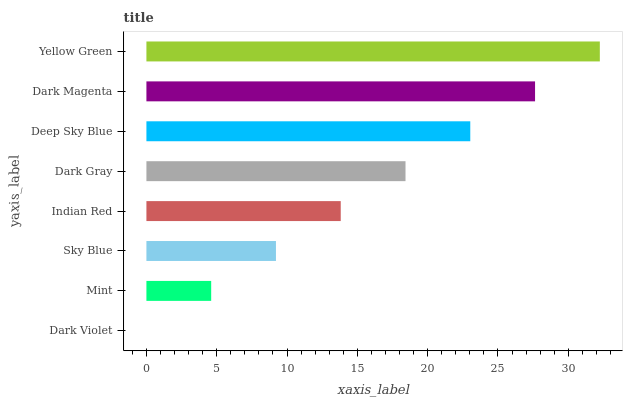Is Dark Violet the minimum?
Answer yes or no. Yes. Is Yellow Green the maximum?
Answer yes or no. Yes. Is Mint the minimum?
Answer yes or no. No. Is Mint the maximum?
Answer yes or no. No. Is Mint greater than Dark Violet?
Answer yes or no. Yes. Is Dark Violet less than Mint?
Answer yes or no. Yes. Is Dark Violet greater than Mint?
Answer yes or no. No. Is Mint less than Dark Violet?
Answer yes or no. No. Is Dark Gray the high median?
Answer yes or no. Yes. Is Indian Red the low median?
Answer yes or no. Yes. Is Dark Magenta the high median?
Answer yes or no. No. Is Dark Gray the low median?
Answer yes or no. No. 